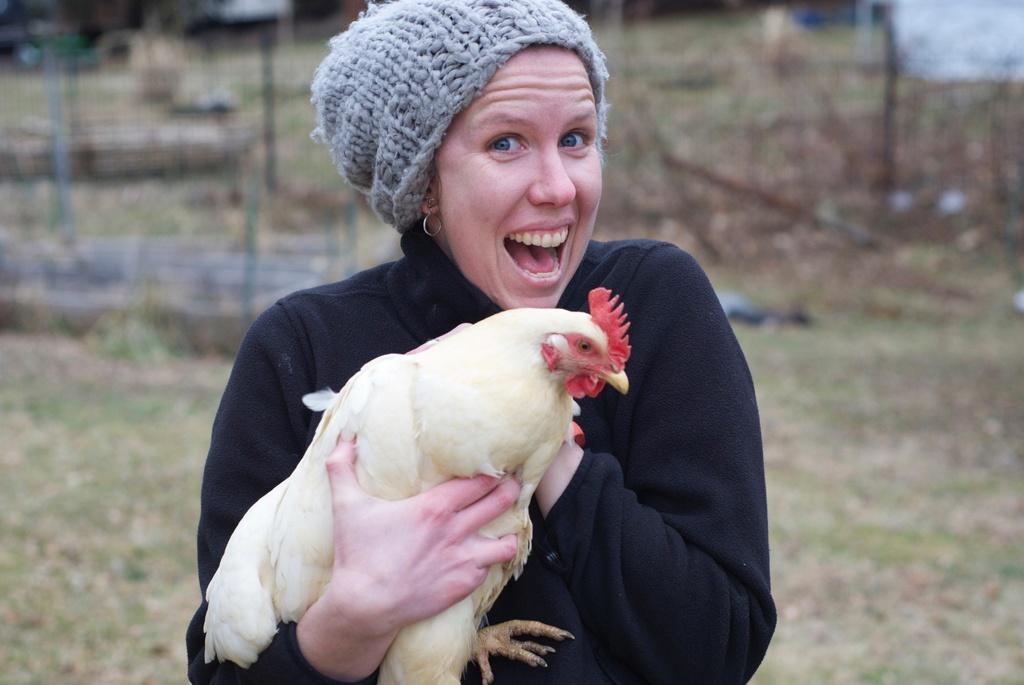How would you summarize this image in a sentence or two? This image consists of a woman wearing a black jacket. And she is holding a hen. At the bottom, there is green grass. In the background, there is a fencing. And the background is blurred. 